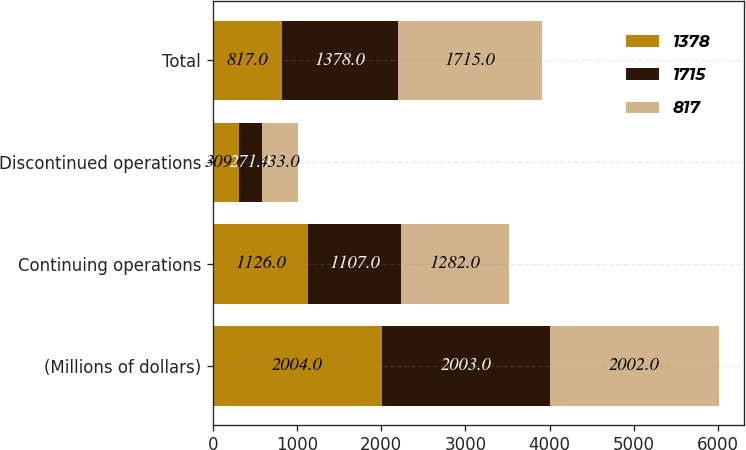Convert chart to OTSL. <chart><loc_0><loc_0><loc_500><loc_500><stacked_bar_chart><ecel><fcel>(Millions of dollars)<fcel>Continuing operations<fcel>Discontinued operations<fcel>Total<nl><fcel>1378<fcel>2004<fcel>1126<fcel>309<fcel>817<nl><fcel>1715<fcel>2003<fcel>1107<fcel>271<fcel>1378<nl><fcel>817<fcel>2002<fcel>1282<fcel>433<fcel>1715<nl></chart> 